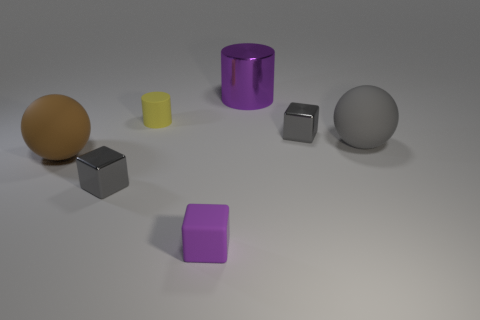Are there any other things that are the same size as the brown thing?
Your answer should be compact. Yes. Is the material of the sphere that is right of the yellow thing the same as the purple block?
Ensure brevity in your answer.  Yes. Are there any other purple blocks of the same size as the matte cube?
Make the answer very short. No. There is a big gray object; is it the same shape as the tiny gray metallic object that is on the right side of the metallic cylinder?
Offer a terse response. No. Is there a cube behind the rubber sphere to the right of the tiny metal block that is right of the tiny purple matte object?
Your answer should be compact. Yes. What size is the brown sphere?
Provide a succinct answer. Large. What number of other things are the same color as the metallic cylinder?
Give a very brief answer. 1. There is a tiny gray metal object behind the big gray thing; does it have the same shape as the big gray thing?
Provide a short and direct response. No. There is another matte object that is the same shape as the brown thing; what color is it?
Give a very brief answer. Gray. Is there any other thing that is the same material as the gray sphere?
Keep it short and to the point. Yes. 